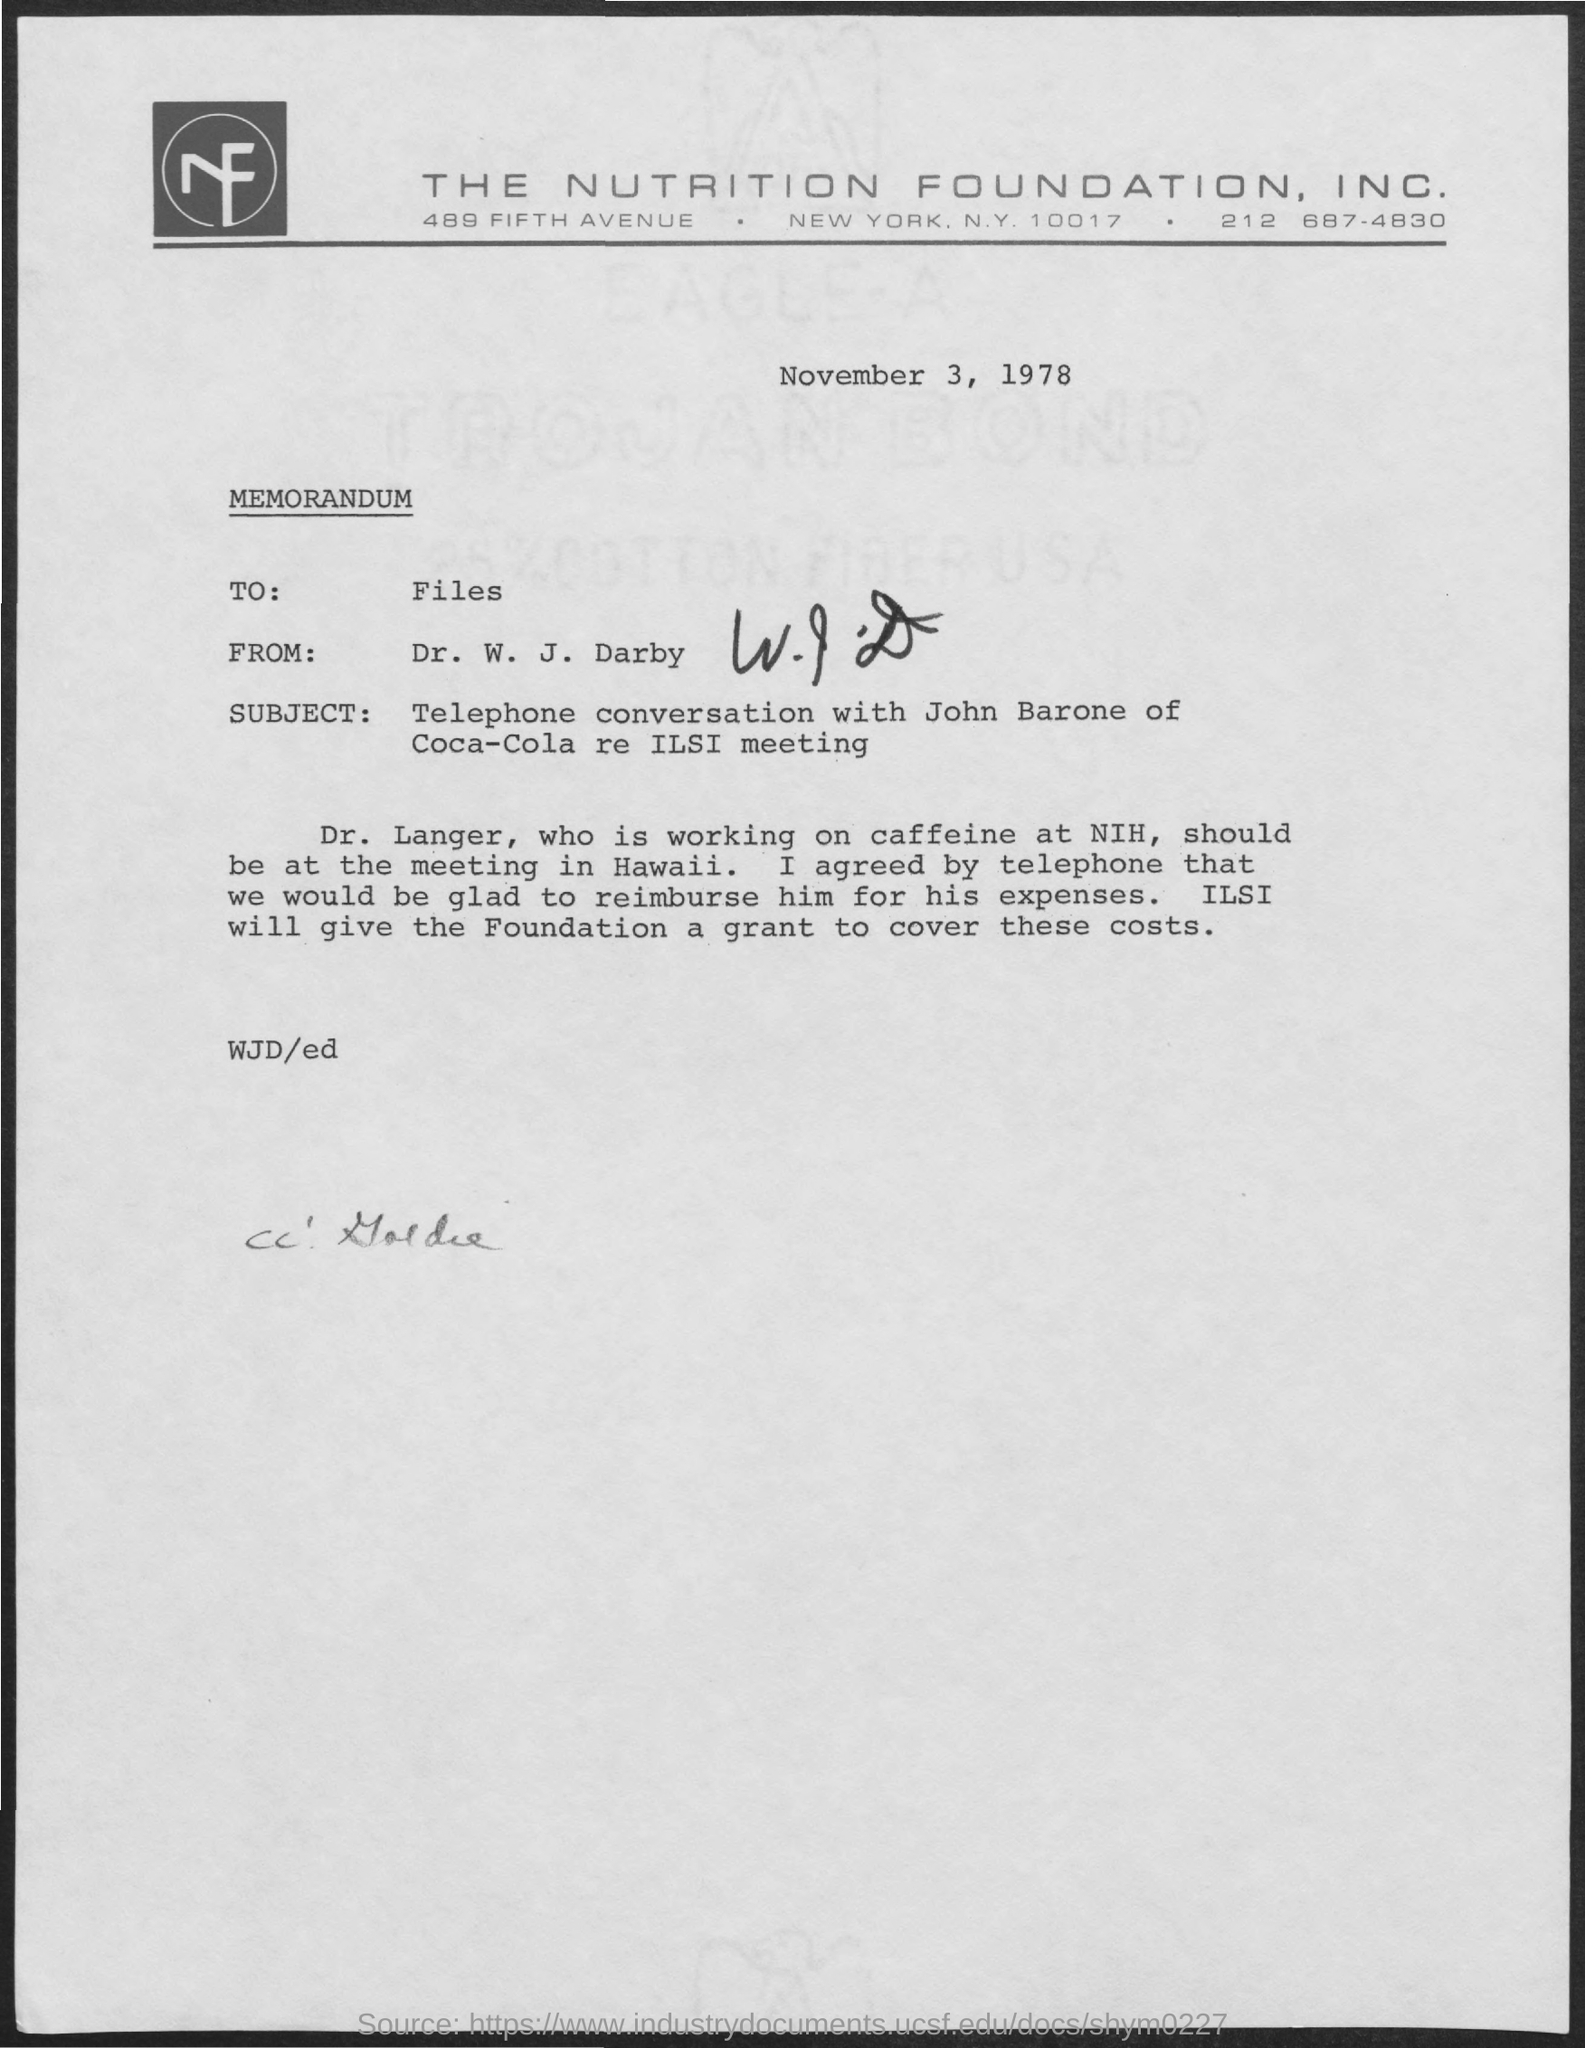List a handful of essential elements in this visual. The date mentioned in the document is November 3, 1978. 